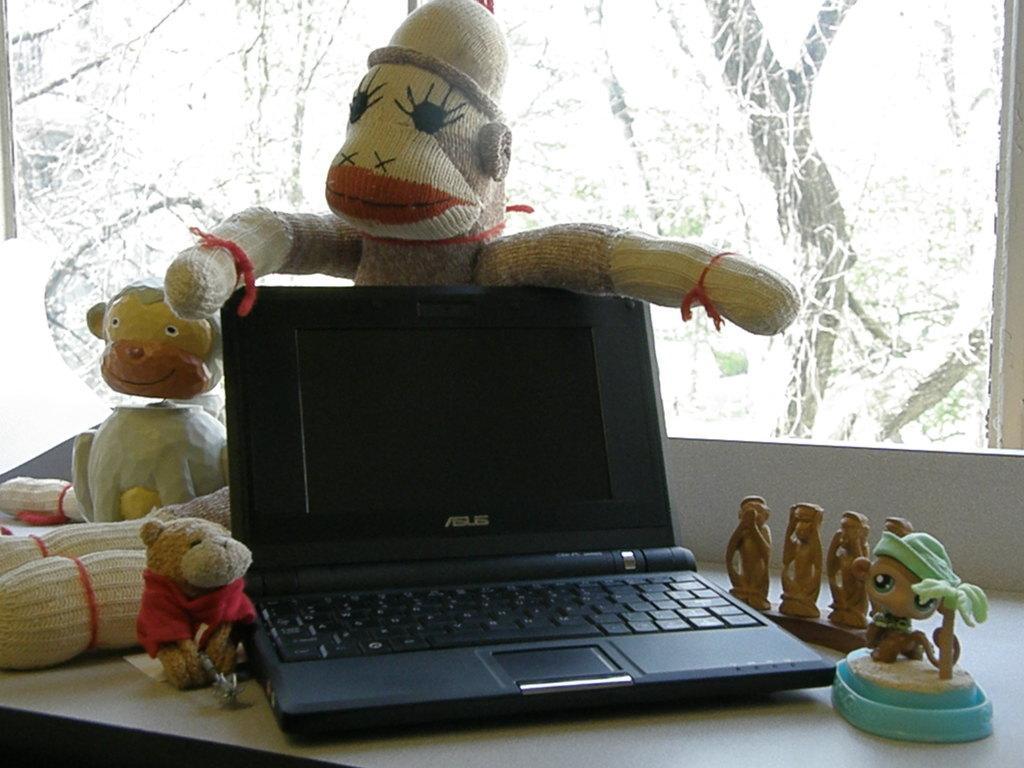In one or two sentences, can you explain what this image depicts? In the picture we can see a table, on the table we can see dolls, and laptop which is black in color and near to it there is a window, from the window we can see a trees, plants. 